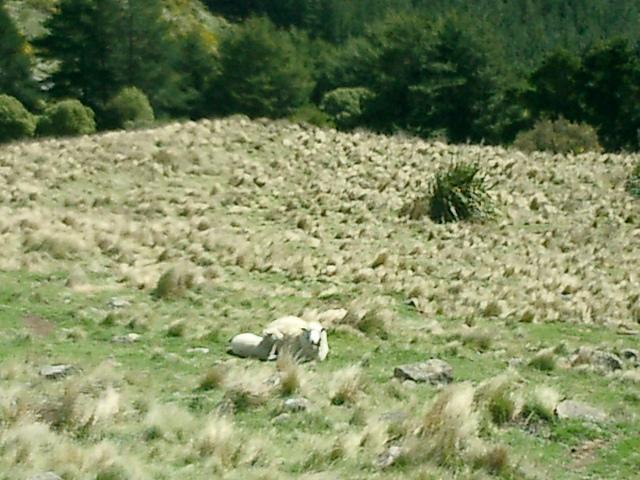What kind of animals are pictured?
Quick response, please. Sheep. Are these animals cared for by humans?
Answer briefly. Yes. What are the sheep doing?
Concise answer only. Laying. What color is the grass?
Be succinct. Green. How many farm animals?
Keep it brief. 2. What kind of creatures are shown?
Concise answer only. Sheep. How many animals are in the field?
Answer briefly. 2. What type of grass is that?
Answer briefly. Prairie. 